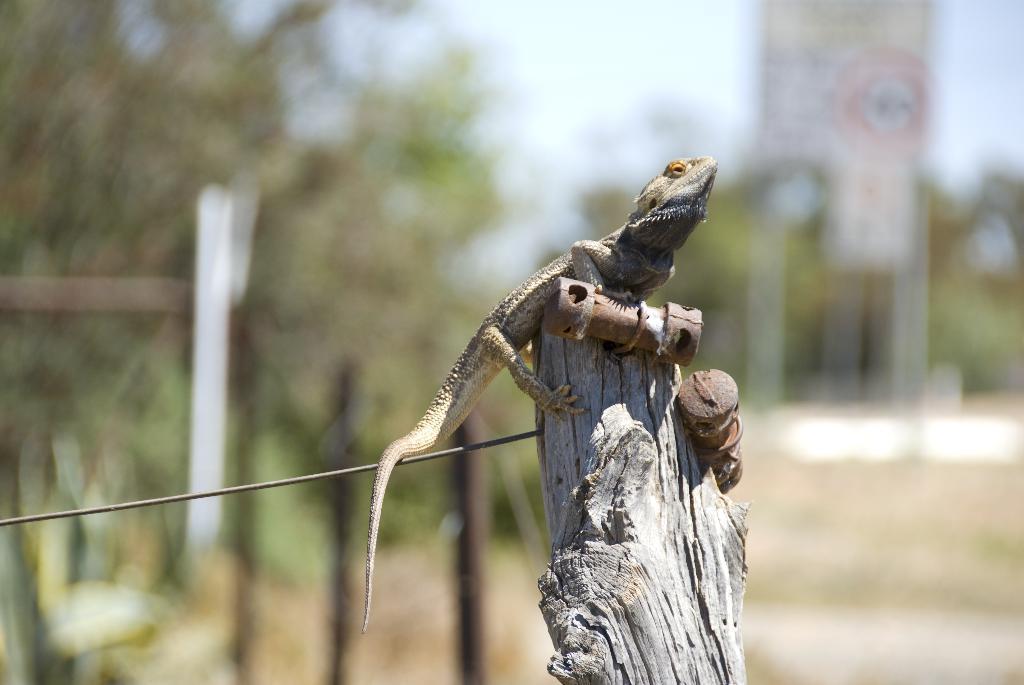Could you give a brief overview of what you see in this image? In this image I see a lizard over here which is on the wooden branch and I see a wire over here and I see that it is blurred in the background. 